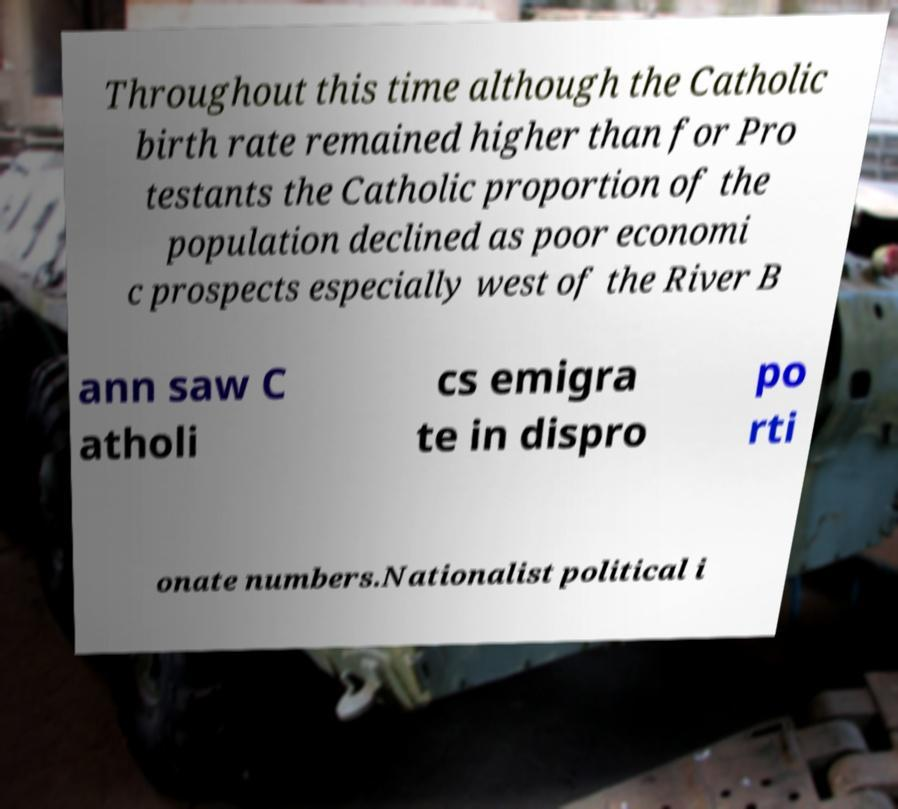Can you read and provide the text displayed in the image?This photo seems to have some interesting text. Can you extract and type it out for me? Throughout this time although the Catholic birth rate remained higher than for Pro testants the Catholic proportion of the population declined as poor economi c prospects especially west of the River B ann saw C atholi cs emigra te in dispro po rti onate numbers.Nationalist political i 